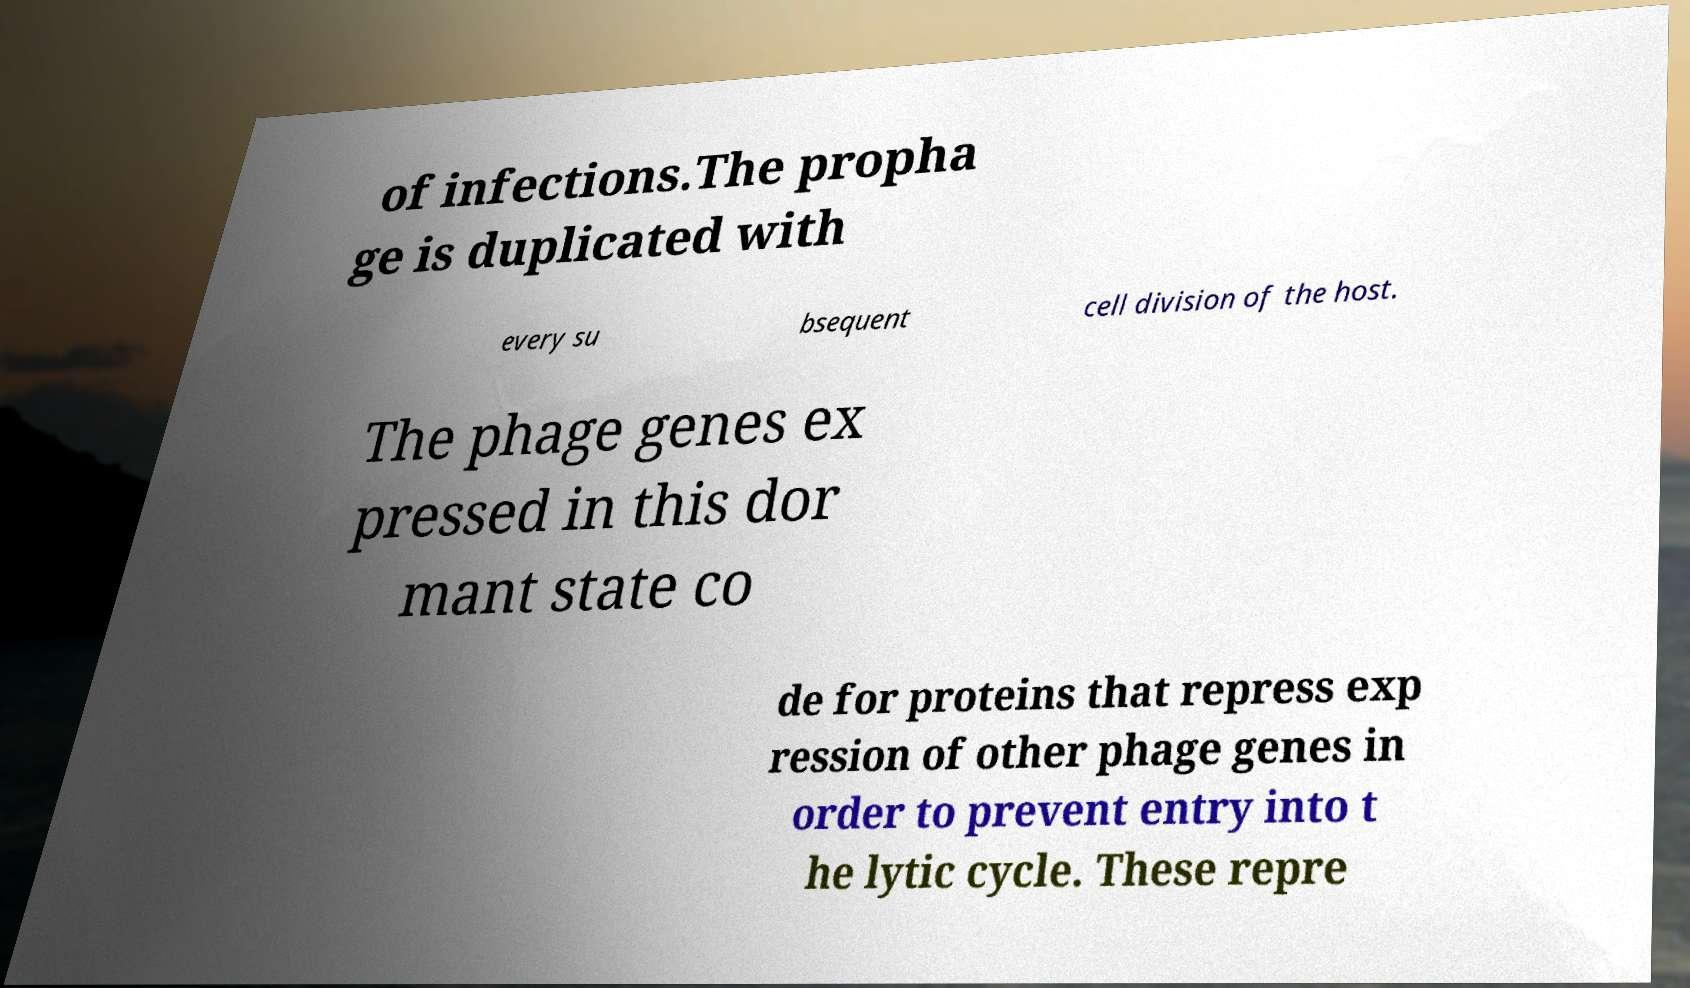Could you extract and type out the text from this image? of infections.The propha ge is duplicated with every su bsequent cell division of the host. The phage genes ex pressed in this dor mant state co de for proteins that repress exp ression of other phage genes in order to prevent entry into t he lytic cycle. These repre 